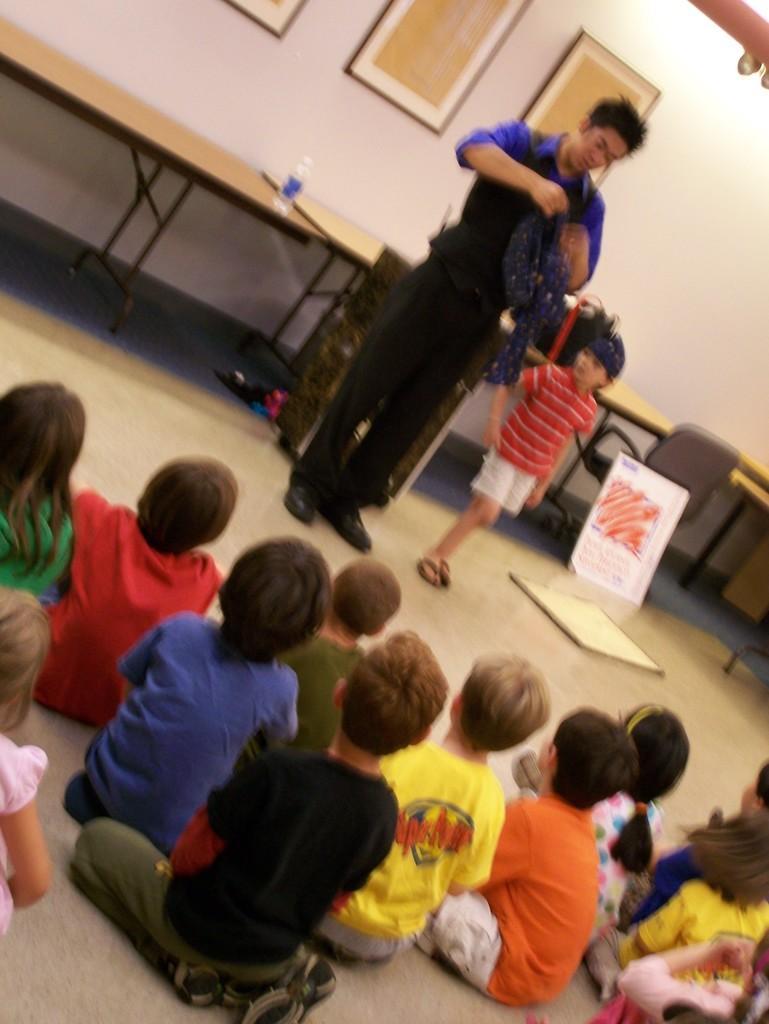In one or two sentences, can you explain what this image depicts? In this picture we can see a group of children sitting on the floor. In front of them we can see a man and a child standing. In the background we can see a bottle, tables, chair, boards, frames on the wall and some objects. 